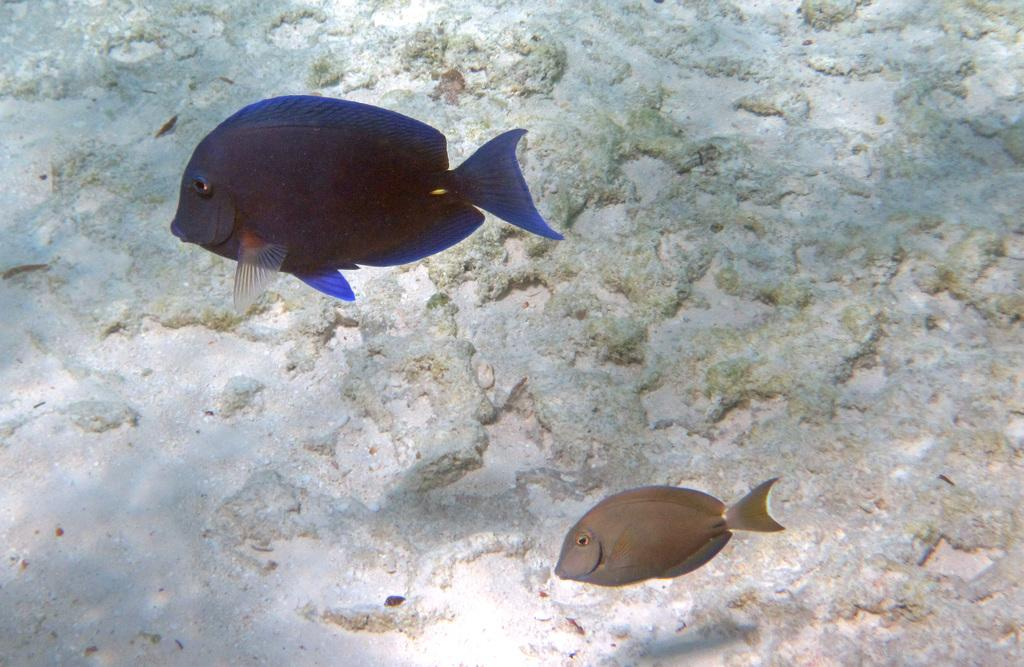What animals are present in the image? There are two fishes in the picture. What can be seen in the background of the image? There are stones in the background of the picture. What type of oatmeal is being prepared in the picture? There is no oatmeal present in the image; it features two fishes and stones in the background. Can you tell me how many scissors are visible in the picture? There are no scissors visible in the picture. 